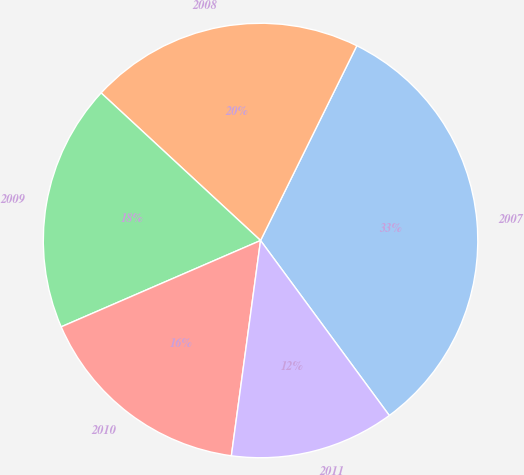Convert chart to OTSL. <chart><loc_0><loc_0><loc_500><loc_500><pie_chart><fcel>2007<fcel>2008<fcel>2009<fcel>2010<fcel>2011<nl><fcel>32.6%<fcel>20.42%<fcel>18.39%<fcel>16.35%<fcel>12.24%<nl></chart> 